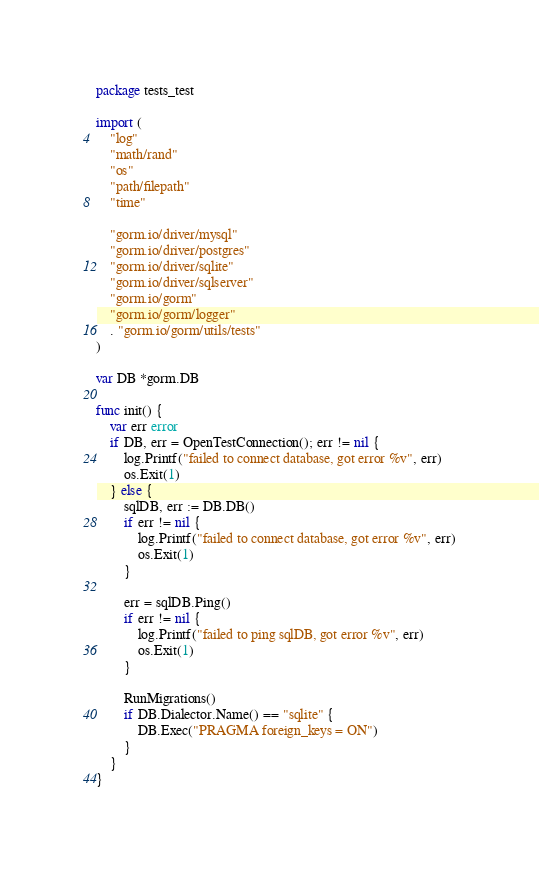<code> <loc_0><loc_0><loc_500><loc_500><_Go_>package tests_test

import (
	"log"
	"math/rand"
	"os"
	"path/filepath"
	"time"

	"gorm.io/driver/mysql"
	"gorm.io/driver/postgres"
	"gorm.io/driver/sqlite"
	"gorm.io/driver/sqlserver"
	"gorm.io/gorm"
	"gorm.io/gorm/logger"
	. "gorm.io/gorm/utils/tests"
)

var DB *gorm.DB

func init() {
	var err error
	if DB, err = OpenTestConnection(); err != nil {
		log.Printf("failed to connect database, got error %v", err)
		os.Exit(1)
	} else {
		sqlDB, err := DB.DB()
		if err != nil {
			log.Printf("failed to connect database, got error %v", err)
			os.Exit(1)
		}

		err = sqlDB.Ping()
		if err != nil {
			log.Printf("failed to ping sqlDB, got error %v", err)
			os.Exit(1)
		}

		RunMigrations()
		if DB.Dialector.Name() == "sqlite" {
			DB.Exec("PRAGMA foreign_keys = ON")
		}
	}
}
</code> 